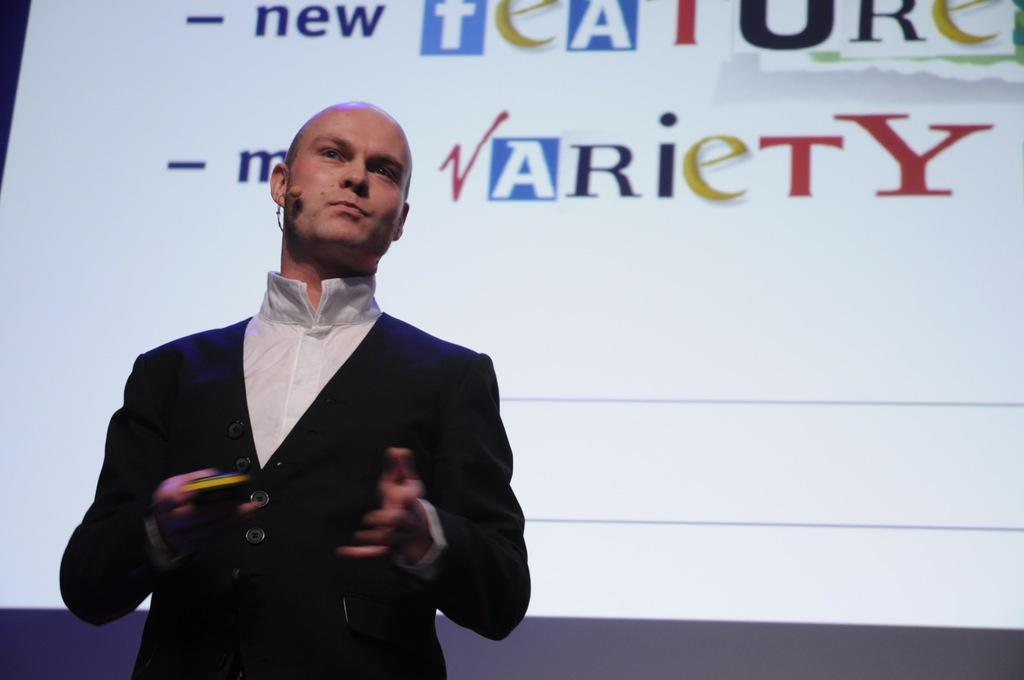What is the main subject in the front of the image? There is a man standing in the front of the image. What can be seen in the background of the image? There is a screen in the background of the image. What is displayed on the screen? The screen displays some text. What type of air is visible around the man in the image? There is no specific type of air mentioned or visible in the image. Are there any police officers present in the image? There is no mention of police officers in the provided facts, so we cannot determine their presence in the image. 